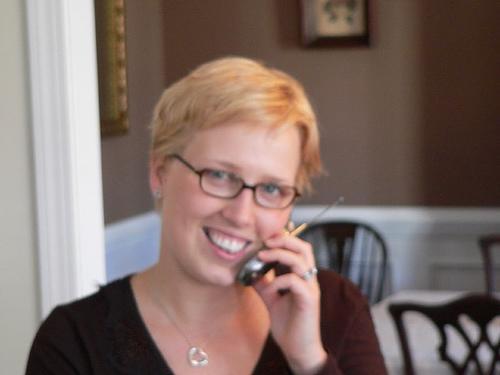How many rings does she have on?
Give a very brief answer. 1. How many chairs are in the photo?
Give a very brief answer. 2. 